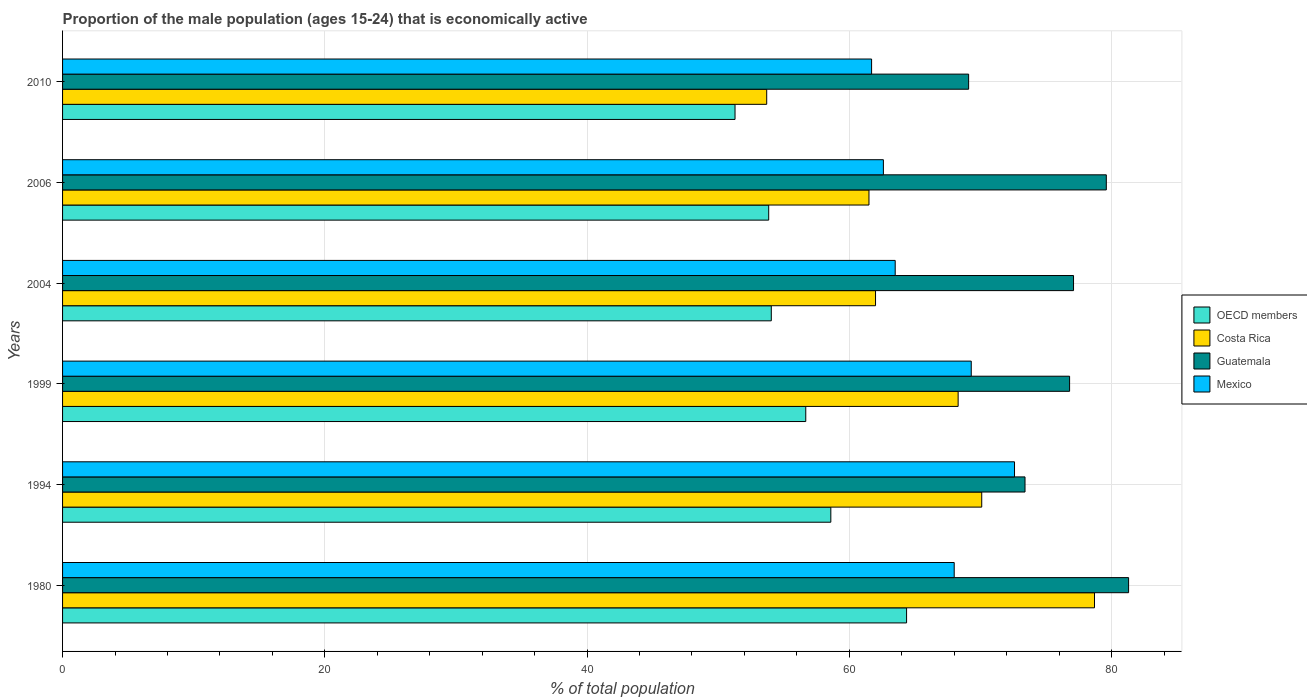How many different coloured bars are there?
Make the answer very short. 4. How many bars are there on the 1st tick from the bottom?
Provide a short and direct response. 4. In how many cases, is the number of bars for a given year not equal to the number of legend labels?
Your response must be concise. 0. What is the proportion of the male population that is economically active in OECD members in 2004?
Provide a short and direct response. 54.05. Across all years, what is the maximum proportion of the male population that is economically active in Guatemala?
Offer a terse response. 81.3. Across all years, what is the minimum proportion of the male population that is economically active in Guatemala?
Your response must be concise. 69.1. In which year was the proportion of the male population that is economically active in OECD members maximum?
Give a very brief answer. 1980. What is the total proportion of the male population that is economically active in Mexico in the graph?
Offer a terse response. 397.7. What is the difference between the proportion of the male population that is economically active in OECD members in 2004 and that in 2006?
Provide a short and direct response. 0.2. What is the difference between the proportion of the male population that is economically active in Guatemala in 1994 and the proportion of the male population that is economically active in OECD members in 1999?
Keep it short and to the point. 16.72. What is the average proportion of the male population that is economically active in Guatemala per year?
Keep it short and to the point. 76.22. In the year 2004, what is the difference between the proportion of the male population that is economically active in Guatemala and proportion of the male population that is economically active in Costa Rica?
Offer a terse response. 15.1. What is the ratio of the proportion of the male population that is economically active in Costa Rica in 1994 to that in 2010?
Keep it short and to the point. 1.31. Is the difference between the proportion of the male population that is economically active in Guatemala in 1994 and 2004 greater than the difference between the proportion of the male population that is economically active in Costa Rica in 1994 and 2004?
Offer a very short reply. No. What is the difference between the highest and the second highest proportion of the male population that is economically active in Guatemala?
Offer a very short reply. 1.7. What is the difference between the highest and the lowest proportion of the male population that is economically active in Mexico?
Keep it short and to the point. 10.9. In how many years, is the proportion of the male population that is economically active in Guatemala greater than the average proportion of the male population that is economically active in Guatemala taken over all years?
Provide a succinct answer. 4. Is the sum of the proportion of the male population that is economically active in OECD members in 1994 and 2004 greater than the maximum proportion of the male population that is economically active in Costa Rica across all years?
Make the answer very short. Yes. What does the 4th bar from the bottom in 1999 represents?
Offer a very short reply. Mexico. Is it the case that in every year, the sum of the proportion of the male population that is economically active in Mexico and proportion of the male population that is economically active in Guatemala is greater than the proportion of the male population that is economically active in Costa Rica?
Your response must be concise. Yes. How many bars are there?
Offer a very short reply. 24. Are all the bars in the graph horizontal?
Give a very brief answer. Yes. Does the graph contain any zero values?
Offer a very short reply. No. How many legend labels are there?
Provide a succinct answer. 4. How are the legend labels stacked?
Make the answer very short. Vertical. What is the title of the graph?
Make the answer very short. Proportion of the male population (ages 15-24) that is economically active. Does "Australia" appear as one of the legend labels in the graph?
Give a very brief answer. No. What is the label or title of the X-axis?
Keep it short and to the point. % of total population. What is the % of total population in OECD members in 1980?
Offer a very short reply. 64.37. What is the % of total population in Costa Rica in 1980?
Provide a succinct answer. 78.7. What is the % of total population of Guatemala in 1980?
Make the answer very short. 81.3. What is the % of total population in Mexico in 1980?
Your answer should be compact. 68. What is the % of total population in OECD members in 1994?
Keep it short and to the point. 58.59. What is the % of total population in Costa Rica in 1994?
Ensure brevity in your answer.  70.1. What is the % of total population of Guatemala in 1994?
Keep it short and to the point. 73.4. What is the % of total population of Mexico in 1994?
Make the answer very short. 72.6. What is the % of total population in OECD members in 1999?
Offer a very short reply. 56.68. What is the % of total population in Costa Rica in 1999?
Provide a succinct answer. 68.3. What is the % of total population of Guatemala in 1999?
Your answer should be compact. 76.8. What is the % of total population of Mexico in 1999?
Provide a succinct answer. 69.3. What is the % of total population in OECD members in 2004?
Make the answer very short. 54.05. What is the % of total population in Guatemala in 2004?
Give a very brief answer. 77.1. What is the % of total population in Mexico in 2004?
Provide a succinct answer. 63.5. What is the % of total population in OECD members in 2006?
Your answer should be compact. 53.85. What is the % of total population in Costa Rica in 2006?
Your answer should be very brief. 61.5. What is the % of total population in Guatemala in 2006?
Your response must be concise. 79.6. What is the % of total population in Mexico in 2006?
Ensure brevity in your answer.  62.6. What is the % of total population of OECD members in 2010?
Give a very brief answer. 51.28. What is the % of total population of Costa Rica in 2010?
Provide a succinct answer. 53.7. What is the % of total population of Guatemala in 2010?
Provide a succinct answer. 69.1. What is the % of total population in Mexico in 2010?
Offer a very short reply. 61.7. Across all years, what is the maximum % of total population of OECD members?
Keep it short and to the point. 64.37. Across all years, what is the maximum % of total population in Costa Rica?
Offer a terse response. 78.7. Across all years, what is the maximum % of total population in Guatemala?
Your response must be concise. 81.3. Across all years, what is the maximum % of total population in Mexico?
Your answer should be compact. 72.6. Across all years, what is the minimum % of total population of OECD members?
Provide a succinct answer. 51.28. Across all years, what is the minimum % of total population of Costa Rica?
Offer a terse response. 53.7. Across all years, what is the minimum % of total population in Guatemala?
Offer a terse response. 69.1. Across all years, what is the minimum % of total population of Mexico?
Offer a very short reply. 61.7. What is the total % of total population of OECD members in the graph?
Ensure brevity in your answer.  338.83. What is the total % of total population of Costa Rica in the graph?
Keep it short and to the point. 394.3. What is the total % of total population in Guatemala in the graph?
Your answer should be very brief. 457.3. What is the total % of total population in Mexico in the graph?
Your answer should be compact. 397.7. What is the difference between the % of total population in OECD members in 1980 and that in 1994?
Your answer should be compact. 5.78. What is the difference between the % of total population of Mexico in 1980 and that in 1994?
Your answer should be compact. -4.6. What is the difference between the % of total population in OECD members in 1980 and that in 1999?
Provide a short and direct response. 7.69. What is the difference between the % of total population of Costa Rica in 1980 and that in 1999?
Provide a short and direct response. 10.4. What is the difference between the % of total population of Guatemala in 1980 and that in 1999?
Your answer should be compact. 4.5. What is the difference between the % of total population in Mexico in 1980 and that in 1999?
Provide a succinct answer. -1.3. What is the difference between the % of total population of OECD members in 1980 and that in 2004?
Provide a succinct answer. 10.32. What is the difference between the % of total population of Costa Rica in 1980 and that in 2004?
Offer a very short reply. 16.7. What is the difference between the % of total population of OECD members in 1980 and that in 2006?
Your response must be concise. 10.51. What is the difference between the % of total population in Costa Rica in 1980 and that in 2006?
Your answer should be very brief. 17.2. What is the difference between the % of total population of Guatemala in 1980 and that in 2006?
Provide a succinct answer. 1.7. What is the difference between the % of total population in Mexico in 1980 and that in 2006?
Provide a short and direct response. 5.4. What is the difference between the % of total population of OECD members in 1980 and that in 2010?
Offer a very short reply. 13.08. What is the difference between the % of total population of OECD members in 1994 and that in 1999?
Give a very brief answer. 1.91. What is the difference between the % of total population in Costa Rica in 1994 and that in 1999?
Provide a succinct answer. 1.8. What is the difference between the % of total population in Guatemala in 1994 and that in 1999?
Provide a succinct answer. -3.4. What is the difference between the % of total population of Mexico in 1994 and that in 1999?
Make the answer very short. 3.3. What is the difference between the % of total population in OECD members in 1994 and that in 2004?
Your response must be concise. 4.54. What is the difference between the % of total population in OECD members in 1994 and that in 2006?
Keep it short and to the point. 4.74. What is the difference between the % of total population of Guatemala in 1994 and that in 2006?
Make the answer very short. -6.2. What is the difference between the % of total population of OECD members in 1994 and that in 2010?
Make the answer very short. 7.31. What is the difference between the % of total population of Mexico in 1994 and that in 2010?
Your answer should be very brief. 10.9. What is the difference between the % of total population in OECD members in 1999 and that in 2004?
Your answer should be compact. 2.63. What is the difference between the % of total population in Costa Rica in 1999 and that in 2004?
Your response must be concise. 6.3. What is the difference between the % of total population in OECD members in 1999 and that in 2006?
Your answer should be compact. 2.83. What is the difference between the % of total population in Guatemala in 1999 and that in 2006?
Give a very brief answer. -2.8. What is the difference between the % of total population of OECD members in 1999 and that in 2010?
Offer a terse response. 5.39. What is the difference between the % of total population of Costa Rica in 1999 and that in 2010?
Provide a succinct answer. 14.6. What is the difference between the % of total population of Guatemala in 1999 and that in 2010?
Provide a short and direct response. 7.7. What is the difference between the % of total population of OECD members in 2004 and that in 2006?
Your answer should be very brief. 0.2. What is the difference between the % of total population of Guatemala in 2004 and that in 2006?
Your answer should be compact. -2.5. What is the difference between the % of total population of OECD members in 2004 and that in 2010?
Keep it short and to the point. 2.77. What is the difference between the % of total population in Guatemala in 2004 and that in 2010?
Ensure brevity in your answer.  8. What is the difference between the % of total population in Mexico in 2004 and that in 2010?
Your answer should be very brief. 1.8. What is the difference between the % of total population of OECD members in 2006 and that in 2010?
Provide a succinct answer. 2.57. What is the difference between the % of total population of Guatemala in 2006 and that in 2010?
Offer a terse response. 10.5. What is the difference between the % of total population in Mexico in 2006 and that in 2010?
Give a very brief answer. 0.9. What is the difference between the % of total population in OECD members in 1980 and the % of total population in Costa Rica in 1994?
Ensure brevity in your answer.  -5.73. What is the difference between the % of total population of OECD members in 1980 and the % of total population of Guatemala in 1994?
Provide a short and direct response. -9.03. What is the difference between the % of total population of OECD members in 1980 and the % of total population of Mexico in 1994?
Offer a very short reply. -8.23. What is the difference between the % of total population of Costa Rica in 1980 and the % of total population of Mexico in 1994?
Make the answer very short. 6.1. What is the difference between the % of total population in OECD members in 1980 and the % of total population in Costa Rica in 1999?
Ensure brevity in your answer.  -3.93. What is the difference between the % of total population in OECD members in 1980 and the % of total population in Guatemala in 1999?
Provide a short and direct response. -12.43. What is the difference between the % of total population of OECD members in 1980 and the % of total population of Mexico in 1999?
Provide a succinct answer. -4.93. What is the difference between the % of total population of Costa Rica in 1980 and the % of total population of Guatemala in 1999?
Keep it short and to the point. 1.9. What is the difference between the % of total population in Costa Rica in 1980 and the % of total population in Mexico in 1999?
Offer a terse response. 9.4. What is the difference between the % of total population of OECD members in 1980 and the % of total population of Costa Rica in 2004?
Ensure brevity in your answer.  2.37. What is the difference between the % of total population of OECD members in 1980 and the % of total population of Guatemala in 2004?
Offer a terse response. -12.73. What is the difference between the % of total population of OECD members in 1980 and the % of total population of Mexico in 2004?
Make the answer very short. 0.87. What is the difference between the % of total population of Costa Rica in 1980 and the % of total population of Mexico in 2004?
Give a very brief answer. 15.2. What is the difference between the % of total population of Guatemala in 1980 and the % of total population of Mexico in 2004?
Keep it short and to the point. 17.8. What is the difference between the % of total population of OECD members in 1980 and the % of total population of Costa Rica in 2006?
Offer a terse response. 2.87. What is the difference between the % of total population in OECD members in 1980 and the % of total population in Guatemala in 2006?
Provide a succinct answer. -15.23. What is the difference between the % of total population in OECD members in 1980 and the % of total population in Mexico in 2006?
Your answer should be very brief. 1.77. What is the difference between the % of total population in Costa Rica in 1980 and the % of total population in Guatemala in 2006?
Offer a terse response. -0.9. What is the difference between the % of total population of OECD members in 1980 and the % of total population of Costa Rica in 2010?
Offer a very short reply. 10.67. What is the difference between the % of total population of OECD members in 1980 and the % of total population of Guatemala in 2010?
Your answer should be very brief. -4.73. What is the difference between the % of total population of OECD members in 1980 and the % of total population of Mexico in 2010?
Your answer should be very brief. 2.67. What is the difference between the % of total population of Costa Rica in 1980 and the % of total population of Mexico in 2010?
Your answer should be compact. 17. What is the difference between the % of total population of Guatemala in 1980 and the % of total population of Mexico in 2010?
Provide a succinct answer. 19.6. What is the difference between the % of total population of OECD members in 1994 and the % of total population of Costa Rica in 1999?
Keep it short and to the point. -9.71. What is the difference between the % of total population in OECD members in 1994 and the % of total population in Guatemala in 1999?
Your response must be concise. -18.21. What is the difference between the % of total population of OECD members in 1994 and the % of total population of Mexico in 1999?
Your answer should be compact. -10.71. What is the difference between the % of total population of Costa Rica in 1994 and the % of total population of Mexico in 1999?
Provide a short and direct response. 0.8. What is the difference between the % of total population of Guatemala in 1994 and the % of total population of Mexico in 1999?
Provide a short and direct response. 4.1. What is the difference between the % of total population in OECD members in 1994 and the % of total population in Costa Rica in 2004?
Make the answer very short. -3.41. What is the difference between the % of total population of OECD members in 1994 and the % of total population of Guatemala in 2004?
Offer a terse response. -18.51. What is the difference between the % of total population of OECD members in 1994 and the % of total population of Mexico in 2004?
Give a very brief answer. -4.91. What is the difference between the % of total population in OECD members in 1994 and the % of total population in Costa Rica in 2006?
Make the answer very short. -2.91. What is the difference between the % of total population in OECD members in 1994 and the % of total population in Guatemala in 2006?
Your response must be concise. -21.01. What is the difference between the % of total population of OECD members in 1994 and the % of total population of Mexico in 2006?
Make the answer very short. -4.01. What is the difference between the % of total population of Costa Rica in 1994 and the % of total population of Guatemala in 2006?
Ensure brevity in your answer.  -9.5. What is the difference between the % of total population in Costa Rica in 1994 and the % of total population in Mexico in 2006?
Ensure brevity in your answer.  7.5. What is the difference between the % of total population of Guatemala in 1994 and the % of total population of Mexico in 2006?
Provide a short and direct response. 10.8. What is the difference between the % of total population of OECD members in 1994 and the % of total population of Costa Rica in 2010?
Ensure brevity in your answer.  4.89. What is the difference between the % of total population in OECD members in 1994 and the % of total population in Guatemala in 2010?
Ensure brevity in your answer.  -10.51. What is the difference between the % of total population of OECD members in 1994 and the % of total population of Mexico in 2010?
Ensure brevity in your answer.  -3.11. What is the difference between the % of total population of Costa Rica in 1994 and the % of total population of Mexico in 2010?
Your answer should be compact. 8.4. What is the difference between the % of total population in Guatemala in 1994 and the % of total population in Mexico in 2010?
Ensure brevity in your answer.  11.7. What is the difference between the % of total population in OECD members in 1999 and the % of total population in Costa Rica in 2004?
Your answer should be very brief. -5.32. What is the difference between the % of total population in OECD members in 1999 and the % of total population in Guatemala in 2004?
Your answer should be compact. -20.42. What is the difference between the % of total population of OECD members in 1999 and the % of total population of Mexico in 2004?
Your answer should be very brief. -6.82. What is the difference between the % of total population of Costa Rica in 1999 and the % of total population of Mexico in 2004?
Provide a short and direct response. 4.8. What is the difference between the % of total population of Guatemala in 1999 and the % of total population of Mexico in 2004?
Keep it short and to the point. 13.3. What is the difference between the % of total population in OECD members in 1999 and the % of total population in Costa Rica in 2006?
Give a very brief answer. -4.82. What is the difference between the % of total population in OECD members in 1999 and the % of total population in Guatemala in 2006?
Offer a terse response. -22.92. What is the difference between the % of total population in OECD members in 1999 and the % of total population in Mexico in 2006?
Offer a terse response. -5.92. What is the difference between the % of total population in Costa Rica in 1999 and the % of total population in Guatemala in 2006?
Offer a very short reply. -11.3. What is the difference between the % of total population in Costa Rica in 1999 and the % of total population in Mexico in 2006?
Your answer should be compact. 5.7. What is the difference between the % of total population of OECD members in 1999 and the % of total population of Costa Rica in 2010?
Your response must be concise. 2.98. What is the difference between the % of total population of OECD members in 1999 and the % of total population of Guatemala in 2010?
Keep it short and to the point. -12.42. What is the difference between the % of total population of OECD members in 1999 and the % of total population of Mexico in 2010?
Offer a terse response. -5.02. What is the difference between the % of total population in Costa Rica in 1999 and the % of total population in Guatemala in 2010?
Your response must be concise. -0.8. What is the difference between the % of total population of OECD members in 2004 and the % of total population of Costa Rica in 2006?
Your answer should be compact. -7.45. What is the difference between the % of total population of OECD members in 2004 and the % of total population of Guatemala in 2006?
Offer a terse response. -25.55. What is the difference between the % of total population in OECD members in 2004 and the % of total population in Mexico in 2006?
Offer a terse response. -8.55. What is the difference between the % of total population of Costa Rica in 2004 and the % of total population of Guatemala in 2006?
Ensure brevity in your answer.  -17.6. What is the difference between the % of total population of Guatemala in 2004 and the % of total population of Mexico in 2006?
Keep it short and to the point. 14.5. What is the difference between the % of total population in OECD members in 2004 and the % of total population in Costa Rica in 2010?
Offer a very short reply. 0.35. What is the difference between the % of total population in OECD members in 2004 and the % of total population in Guatemala in 2010?
Provide a succinct answer. -15.05. What is the difference between the % of total population of OECD members in 2004 and the % of total population of Mexico in 2010?
Your answer should be very brief. -7.65. What is the difference between the % of total population in Guatemala in 2004 and the % of total population in Mexico in 2010?
Give a very brief answer. 15.4. What is the difference between the % of total population in OECD members in 2006 and the % of total population in Costa Rica in 2010?
Make the answer very short. 0.15. What is the difference between the % of total population in OECD members in 2006 and the % of total population in Guatemala in 2010?
Make the answer very short. -15.25. What is the difference between the % of total population in OECD members in 2006 and the % of total population in Mexico in 2010?
Provide a short and direct response. -7.85. What is the difference between the % of total population of Costa Rica in 2006 and the % of total population of Guatemala in 2010?
Your response must be concise. -7.6. What is the average % of total population of OECD members per year?
Provide a short and direct response. 56.47. What is the average % of total population in Costa Rica per year?
Your answer should be compact. 65.72. What is the average % of total population in Guatemala per year?
Provide a short and direct response. 76.22. What is the average % of total population of Mexico per year?
Keep it short and to the point. 66.28. In the year 1980, what is the difference between the % of total population in OECD members and % of total population in Costa Rica?
Your response must be concise. -14.33. In the year 1980, what is the difference between the % of total population of OECD members and % of total population of Guatemala?
Your answer should be very brief. -16.93. In the year 1980, what is the difference between the % of total population in OECD members and % of total population in Mexico?
Your response must be concise. -3.63. In the year 1980, what is the difference between the % of total population of Costa Rica and % of total population of Mexico?
Offer a terse response. 10.7. In the year 1994, what is the difference between the % of total population in OECD members and % of total population in Costa Rica?
Make the answer very short. -11.51. In the year 1994, what is the difference between the % of total population in OECD members and % of total population in Guatemala?
Provide a short and direct response. -14.81. In the year 1994, what is the difference between the % of total population in OECD members and % of total population in Mexico?
Provide a succinct answer. -14.01. In the year 1999, what is the difference between the % of total population of OECD members and % of total population of Costa Rica?
Keep it short and to the point. -11.62. In the year 1999, what is the difference between the % of total population of OECD members and % of total population of Guatemala?
Provide a short and direct response. -20.12. In the year 1999, what is the difference between the % of total population in OECD members and % of total population in Mexico?
Ensure brevity in your answer.  -12.62. In the year 1999, what is the difference between the % of total population in Costa Rica and % of total population in Guatemala?
Offer a terse response. -8.5. In the year 1999, what is the difference between the % of total population in Costa Rica and % of total population in Mexico?
Make the answer very short. -1. In the year 2004, what is the difference between the % of total population of OECD members and % of total population of Costa Rica?
Your answer should be compact. -7.95. In the year 2004, what is the difference between the % of total population in OECD members and % of total population in Guatemala?
Ensure brevity in your answer.  -23.05. In the year 2004, what is the difference between the % of total population of OECD members and % of total population of Mexico?
Provide a short and direct response. -9.45. In the year 2004, what is the difference between the % of total population in Costa Rica and % of total population in Guatemala?
Provide a succinct answer. -15.1. In the year 2004, what is the difference between the % of total population in Costa Rica and % of total population in Mexico?
Provide a succinct answer. -1.5. In the year 2006, what is the difference between the % of total population of OECD members and % of total population of Costa Rica?
Provide a succinct answer. -7.65. In the year 2006, what is the difference between the % of total population of OECD members and % of total population of Guatemala?
Provide a short and direct response. -25.75. In the year 2006, what is the difference between the % of total population in OECD members and % of total population in Mexico?
Offer a very short reply. -8.75. In the year 2006, what is the difference between the % of total population of Costa Rica and % of total population of Guatemala?
Offer a very short reply. -18.1. In the year 2006, what is the difference between the % of total population in Guatemala and % of total population in Mexico?
Make the answer very short. 17. In the year 2010, what is the difference between the % of total population in OECD members and % of total population in Costa Rica?
Provide a succinct answer. -2.42. In the year 2010, what is the difference between the % of total population in OECD members and % of total population in Guatemala?
Your response must be concise. -17.82. In the year 2010, what is the difference between the % of total population of OECD members and % of total population of Mexico?
Make the answer very short. -10.42. In the year 2010, what is the difference between the % of total population of Costa Rica and % of total population of Guatemala?
Give a very brief answer. -15.4. What is the ratio of the % of total population in OECD members in 1980 to that in 1994?
Offer a very short reply. 1.1. What is the ratio of the % of total population of Costa Rica in 1980 to that in 1994?
Provide a short and direct response. 1.12. What is the ratio of the % of total population of Guatemala in 1980 to that in 1994?
Make the answer very short. 1.11. What is the ratio of the % of total population in Mexico in 1980 to that in 1994?
Provide a succinct answer. 0.94. What is the ratio of the % of total population of OECD members in 1980 to that in 1999?
Your answer should be very brief. 1.14. What is the ratio of the % of total population in Costa Rica in 1980 to that in 1999?
Keep it short and to the point. 1.15. What is the ratio of the % of total population of Guatemala in 1980 to that in 1999?
Provide a succinct answer. 1.06. What is the ratio of the % of total population in Mexico in 1980 to that in 1999?
Offer a very short reply. 0.98. What is the ratio of the % of total population in OECD members in 1980 to that in 2004?
Offer a very short reply. 1.19. What is the ratio of the % of total population of Costa Rica in 1980 to that in 2004?
Your answer should be very brief. 1.27. What is the ratio of the % of total population of Guatemala in 1980 to that in 2004?
Provide a short and direct response. 1.05. What is the ratio of the % of total population in Mexico in 1980 to that in 2004?
Offer a very short reply. 1.07. What is the ratio of the % of total population in OECD members in 1980 to that in 2006?
Your answer should be compact. 1.2. What is the ratio of the % of total population of Costa Rica in 1980 to that in 2006?
Your response must be concise. 1.28. What is the ratio of the % of total population of Guatemala in 1980 to that in 2006?
Ensure brevity in your answer.  1.02. What is the ratio of the % of total population of Mexico in 1980 to that in 2006?
Make the answer very short. 1.09. What is the ratio of the % of total population of OECD members in 1980 to that in 2010?
Give a very brief answer. 1.26. What is the ratio of the % of total population of Costa Rica in 1980 to that in 2010?
Your answer should be very brief. 1.47. What is the ratio of the % of total population of Guatemala in 1980 to that in 2010?
Give a very brief answer. 1.18. What is the ratio of the % of total population in Mexico in 1980 to that in 2010?
Make the answer very short. 1.1. What is the ratio of the % of total population of OECD members in 1994 to that in 1999?
Your answer should be compact. 1.03. What is the ratio of the % of total population of Costa Rica in 1994 to that in 1999?
Your response must be concise. 1.03. What is the ratio of the % of total population of Guatemala in 1994 to that in 1999?
Provide a short and direct response. 0.96. What is the ratio of the % of total population in Mexico in 1994 to that in 1999?
Your answer should be very brief. 1.05. What is the ratio of the % of total population of OECD members in 1994 to that in 2004?
Your answer should be compact. 1.08. What is the ratio of the % of total population in Costa Rica in 1994 to that in 2004?
Provide a succinct answer. 1.13. What is the ratio of the % of total population in Guatemala in 1994 to that in 2004?
Keep it short and to the point. 0.95. What is the ratio of the % of total population of Mexico in 1994 to that in 2004?
Provide a short and direct response. 1.14. What is the ratio of the % of total population in OECD members in 1994 to that in 2006?
Offer a very short reply. 1.09. What is the ratio of the % of total population of Costa Rica in 1994 to that in 2006?
Your response must be concise. 1.14. What is the ratio of the % of total population of Guatemala in 1994 to that in 2006?
Offer a very short reply. 0.92. What is the ratio of the % of total population of Mexico in 1994 to that in 2006?
Your answer should be compact. 1.16. What is the ratio of the % of total population of OECD members in 1994 to that in 2010?
Offer a terse response. 1.14. What is the ratio of the % of total population of Costa Rica in 1994 to that in 2010?
Your answer should be very brief. 1.31. What is the ratio of the % of total population in Guatemala in 1994 to that in 2010?
Offer a very short reply. 1.06. What is the ratio of the % of total population of Mexico in 1994 to that in 2010?
Give a very brief answer. 1.18. What is the ratio of the % of total population of OECD members in 1999 to that in 2004?
Provide a succinct answer. 1.05. What is the ratio of the % of total population in Costa Rica in 1999 to that in 2004?
Give a very brief answer. 1.1. What is the ratio of the % of total population in Guatemala in 1999 to that in 2004?
Give a very brief answer. 1. What is the ratio of the % of total population of Mexico in 1999 to that in 2004?
Your answer should be very brief. 1.09. What is the ratio of the % of total population of OECD members in 1999 to that in 2006?
Your answer should be compact. 1.05. What is the ratio of the % of total population in Costa Rica in 1999 to that in 2006?
Your response must be concise. 1.11. What is the ratio of the % of total population of Guatemala in 1999 to that in 2006?
Your answer should be very brief. 0.96. What is the ratio of the % of total population of Mexico in 1999 to that in 2006?
Offer a terse response. 1.11. What is the ratio of the % of total population in OECD members in 1999 to that in 2010?
Your answer should be very brief. 1.11. What is the ratio of the % of total population of Costa Rica in 1999 to that in 2010?
Give a very brief answer. 1.27. What is the ratio of the % of total population in Guatemala in 1999 to that in 2010?
Offer a very short reply. 1.11. What is the ratio of the % of total population in Mexico in 1999 to that in 2010?
Ensure brevity in your answer.  1.12. What is the ratio of the % of total population of OECD members in 2004 to that in 2006?
Make the answer very short. 1. What is the ratio of the % of total population in Guatemala in 2004 to that in 2006?
Your answer should be very brief. 0.97. What is the ratio of the % of total population of Mexico in 2004 to that in 2006?
Provide a succinct answer. 1.01. What is the ratio of the % of total population in OECD members in 2004 to that in 2010?
Keep it short and to the point. 1.05. What is the ratio of the % of total population in Costa Rica in 2004 to that in 2010?
Ensure brevity in your answer.  1.15. What is the ratio of the % of total population in Guatemala in 2004 to that in 2010?
Provide a succinct answer. 1.12. What is the ratio of the % of total population of Mexico in 2004 to that in 2010?
Offer a terse response. 1.03. What is the ratio of the % of total population in OECD members in 2006 to that in 2010?
Your answer should be compact. 1.05. What is the ratio of the % of total population in Costa Rica in 2006 to that in 2010?
Ensure brevity in your answer.  1.15. What is the ratio of the % of total population of Guatemala in 2006 to that in 2010?
Your answer should be compact. 1.15. What is the ratio of the % of total population of Mexico in 2006 to that in 2010?
Your answer should be very brief. 1.01. What is the difference between the highest and the second highest % of total population of OECD members?
Offer a terse response. 5.78. What is the difference between the highest and the second highest % of total population of Mexico?
Provide a short and direct response. 3.3. What is the difference between the highest and the lowest % of total population in OECD members?
Your response must be concise. 13.08. What is the difference between the highest and the lowest % of total population in Costa Rica?
Your answer should be compact. 25. What is the difference between the highest and the lowest % of total population in Guatemala?
Provide a short and direct response. 12.2. What is the difference between the highest and the lowest % of total population of Mexico?
Provide a short and direct response. 10.9. 